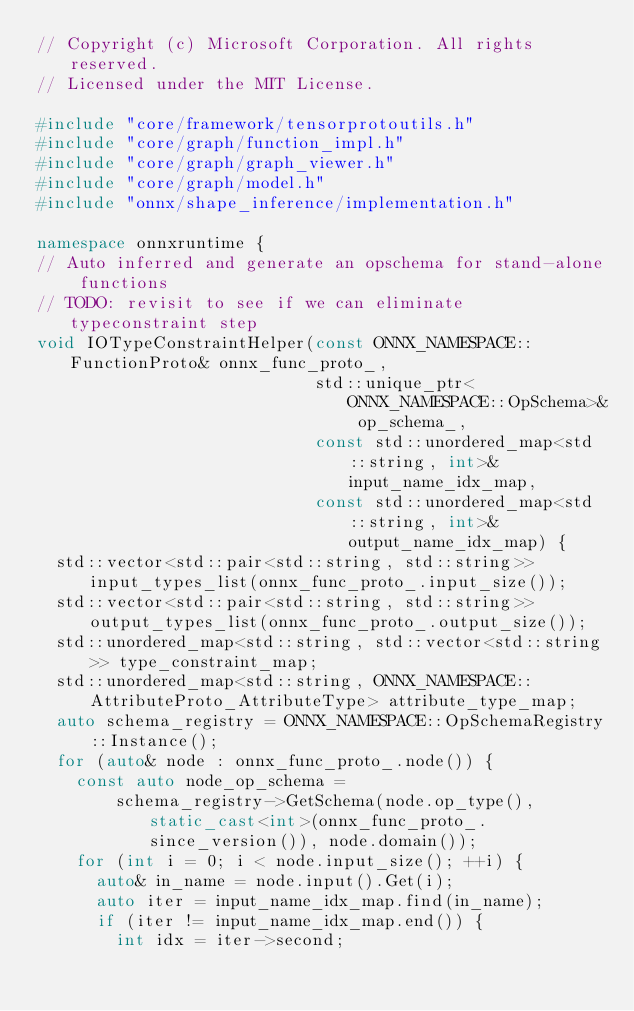<code> <loc_0><loc_0><loc_500><loc_500><_C++_>// Copyright (c) Microsoft Corporation. All rights reserved.
// Licensed under the MIT License.

#include "core/framework/tensorprotoutils.h"
#include "core/graph/function_impl.h"
#include "core/graph/graph_viewer.h"
#include "core/graph/model.h"
#include "onnx/shape_inference/implementation.h"

namespace onnxruntime {
// Auto inferred and generate an opschema for stand-alone functions
// TODO: revisit to see if we can eliminate typeconstraint step
void IOTypeConstraintHelper(const ONNX_NAMESPACE::FunctionProto& onnx_func_proto_,
                            std::unique_ptr<ONNX_NAMESPACE::OpSchema>& op_schema_,
                            const std::unordered_map<std::string, int>& input_name_idx_map,
                            const std::unordered_map<std::string, int>& output_name_idx_map) {
  std::vector<std::pair<std::string, std::string>> input_types_list(onnx_func_proto_.input_size());
  std::vector<std::pair<std::string, std::string>> output_types_list(onnx_func_proto_.output_size());
  std::unordered_map<std::string, std::vector<std::string>> type_constraint_map;
  std::unordered_map<std::string, ONNX_NAMESPACE::AttributeProto_AttributeType> attribute_type_map;
  auto schema_registry = ONNX_NAMESPACE::OpSchemaRegistry::Instance();
  for (auto& node : onnx_func_proto_.node()) {
    const auto node_op_schema =
        schema_registry->GetSchema(node.op_type(), static_cast<int>(onnx_func_proto_.since_version()), node.domain());
    for (int i = 0; i < node.input_size(); ++i) {
      auto& in_name = node.input().Get(i);
      auto iter = input_name_idx_map.find(in_name);
      if (iter != input_name_idx_map.end()) {
        int idx = iter->second;</code> 